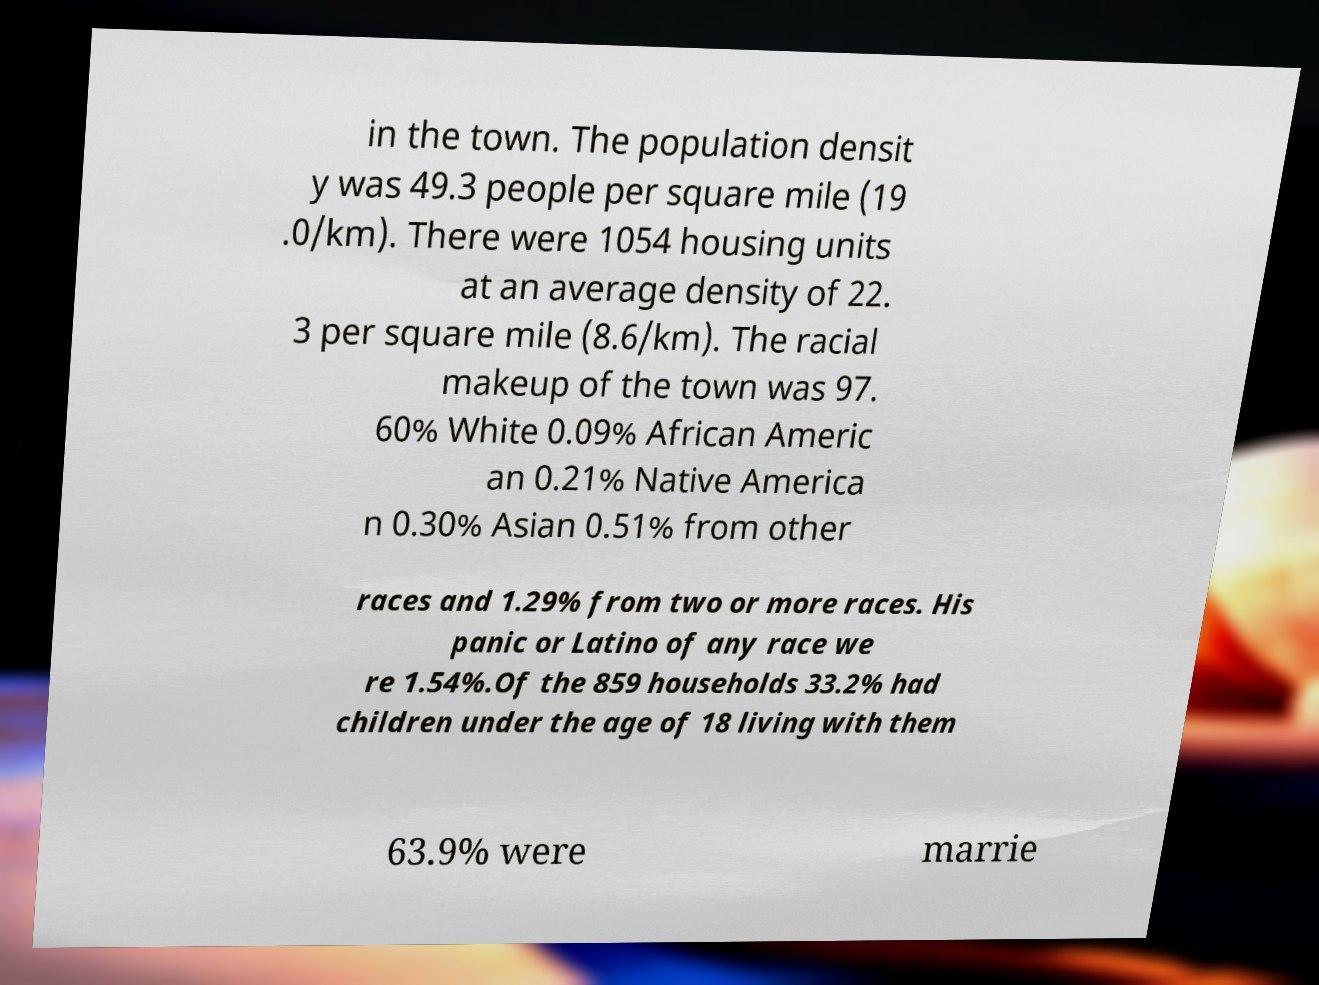Could you extract and type out the text from this image? in the town. The population densit y was 49.3 people per square mile (19 .0/km). There were 1054 housing units at an average density of 22. 3 per square mile (8.6/km). The racial makeup of the town was 97. 60% White 0.09% African Americ an 0.21% Native America n 0.30% Asian 0.51% from other races and 1.29% from two or more races. His panic or Latino of any race we re 1.54%.Of the 859 households 33.2% had children under the age of 18 living with them 63.9% were marrie 